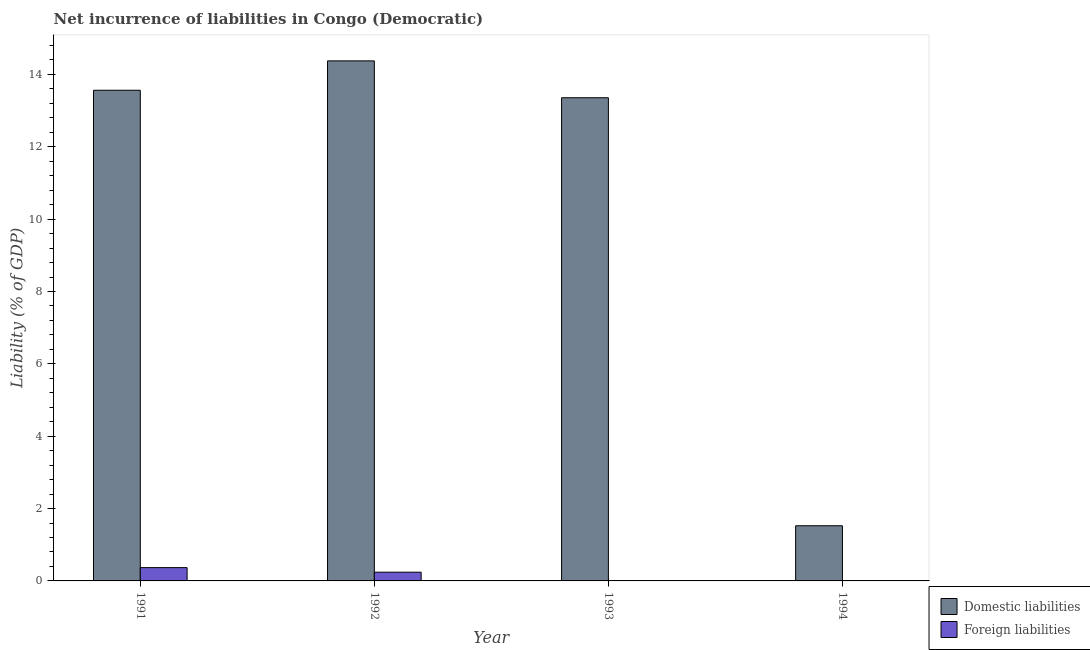Are the number of bars on each tick of the X-axis equal?
Provide a succinct answer. No. What is the incurrence of foreign liabilities in 1991?
Ensure brevity in your answer.  0.37. Across all years, what is the maximum incurrence of domestic liabilities?
Make the answer very short. 14.38. In which year was the incurrence of domestic liabilities maximum?
Keep it short and to the point. 1992. What is the total incurrence of foreign liabilities in the graph?
Offer a terse response. 0.61. What is the difference between the incurrence of domestic liabilities in 1991 and that in 1992?
Your response must be concise. -0.81. What is the difference between the incurrence of domestic liabilities in 1991 and the incurrence of foreign liabilities in 1993?
Your response must be concise. 0.21. What is the average incurrence of domestic liabilities per year?
Give a very brief answer. 10.7. What is the ratio of the incurrence of foreign liabilities in 1991 to that in 1992?
Offer a terse response. 1.52. Is the difference between the incurrence of domestic liabilities in 1993 and 1994 greater than the difference between the incurrence of foreign liabilities in 1993 and 1994?
Your answer should be very brief. No. What is the difference between the highest and the second highest incurrence of domestic liabilities?
Provide a short and direct response. 0.81. What is the difference between the highest and the lowest incurrence of foreign liabilities?
Your answer should be very brief. 0.37. Are all the bars in the graph horizontal?
Offer a very short reply. No. What is the difference between two consecutive major ticks on the Y-axis?
Offer a very short reply. 2. Does the graph contain any zero values?
Offer a terse response. Yes. Does the graph contain grids?
Ensure brevity in your answer.  No. How many legend labels are there?
Ensure brevity in your answer.  2. How are the legend labels stacked?
Give a very brief answer. Vertical. What is the title of the graph?
Your response must be concise. Net incurrence of liabilities in Congo (Democratic). What is the label or title of the X-axis?
Give a very brief answer. Year. What is the label or title of the Y-axis?
Your response must be concise. Liability (% of GDP). What is the Liability (% of GDP) of Domestic liabilities in 1991?
Provide a succinct answer. 13.56. What is the Liability (% of GDP) in Foreign liabilities in 1991?
Offer a terse response. 0.37. What is the Liability (% of GDP) in Domestic liabilities in 1992?
Keep it short and to the point. 14.38. What is the Liability (% of GDP) in Foreign liabilities in 1992?
Keep it short and to the point. 0.24. What is the Liability (% of GDP) in Domestic liabilities in 1993?
Your response must be concise. 13.36. What is the Liability (% of GDP) of Foreign liabilities in 1993?
Give a very brief answer. 0. What is the Liability (% of GDP) in Domestic liabilities in 1994?
Your answer should be very brief. 1.52. Across all years, what is the maximum Liability (% of GDP) in Domestic liabilities?
Offer a terse response. 14.38. Across all years, what is the maximum Liability (% of GDP) of Foreign liabilities?
Your answer should be very brief. 0.37. Across all years, what is the minimum Liability (% of GDP) in Domestic liabilities?
Provide a short and direct response. 1.52. What is the total Liability (% of GDP) of Domestic liabilities in the graph?
Your answer should be compact. 42.82. What is the total Liability (% of GDP) in Foreign liabilities in the graph?
Provide a short and direct response. 0.61. What is the difference between the Liability (% of GDP) of Domestic liabilities in 1991 and that in 1992?
Make the answer very short. -0.81. What is the difference between the Liability (% of GDP) of Foreign liabilities in 1991 and that in 1992?
Offer a very short reply. 0.13. What is the difference between the Liability (% of GDP) of Domestic liabilities in 1991 and that in 1993?
Your answer should be compact. 0.21. What is the difference between the Liability (% of GDP) of Domestic liabilities in 1991 and that in 1994?
Offer a very short reply. 12.04. What is the difference between the Liability (% of GDP) in Domestic liabilities in 1992 and that in 1993?
Offer a very short reply. 1.02. What is the difference between the Liability (% of GDP) of Domestic liabilities in 1992 and that in 1994?
Make the answer very short. 12.85. What is the difference between the Liability (% of GDP) of Domestic liabilities in 1993 and that in 1994?
Give a very brief answer. 11.83. What is the difference between the Liability (% of GDP) of Domestic liabilities in 1991 and the Liability (% of GDP) of Foreign liabilities in 1992?
Keep it short and to the point. 13.32. What is the average Liability (% of GDP) in Domestic liabilities per year?
Your answer should be very brief. 10.71. What is the average Liability (% of GDP) of Foreign liabilities per year?
Provide a short and direct response. 0.15. In the year 1991, what is the difference between the Liability (% of GDP) in Domestic liabilities and Liability (% of GDP) in Foreign liabilities?
Your answer should be very brief. 13.2. In the year 1992, what is the difference between the Liability (% of GDP) of Domestic liabilities and Liability (% of GDP) of Foreign liabilities?
Your answer should be compact. 14.13. What is the ratio of the Liability (% of GDP) of Domestic liabilities in 1991 to that in 1992?
Keep it short and to the point. 0.94. What is the ratio of the Liability (% of GDP) in Foreign liabilities in 1991 to that in 1992?
Your answer should be compact. 1.52. What is the ratio of the Liability (% of GDP) in Domestic liabilities in 1991 to that in 1993?
Make the answer very short. 1.02. What is the ratio of the Liability (% of GDP) in Domestic liabilities in 1991 to that in 1994?
Your answer should be very brief. 8.89. What is the ratio of the Liability (% of GDP) of Domestic liabilities in 1992 to that in 1993?
Ensure brevity in your answer.  1.08. What is the ratio of the Liability (% of GDP) in Domestic liabilities in 1992 to that in 1994?
Offer a very short reply. 9.43. What is the ratio of the Liability (% of GDP) in Domestic liabilities in 1993 to that in 1994?
Give a very brief answer. 8.76. What is the difference between the highest and the second highest Liability (% of GDP) of Domestic liabilities?
Keep it short and to the point. 0.81. What is the difference between the highest and the lowest Liability (% of GDP) of Domestic liabilities?
Make the answer very short. 12.85. What is the difference between the highest and the lowest Liability (% of GDP) in Foreign liabilities?
Make the answer very short. 0.37. 